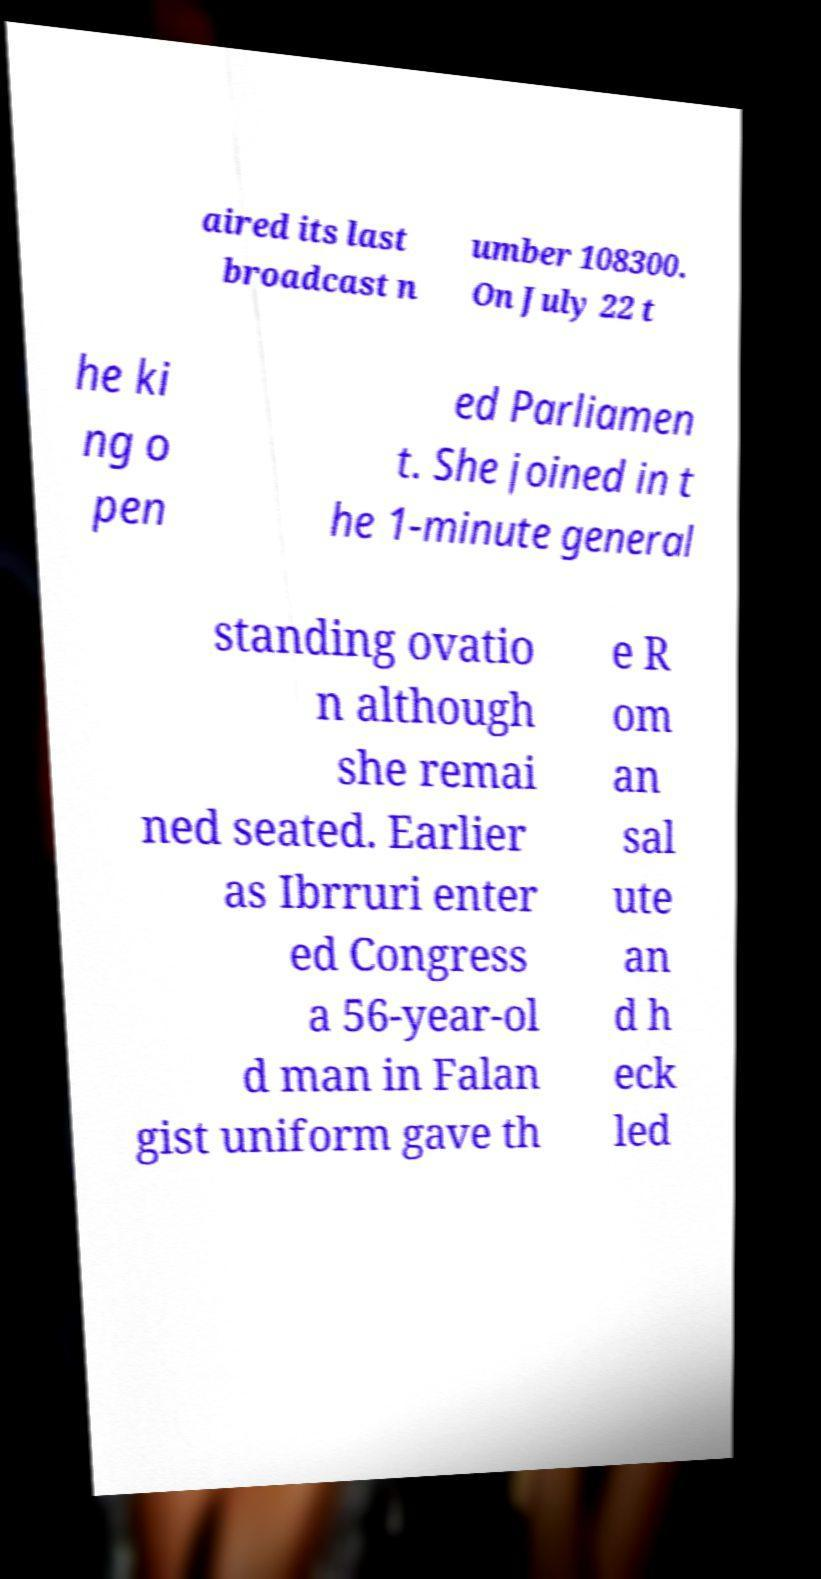Could you extract and type out the text from this image? aired its last broadcast n umber 108300. On July 22 t he ki ng o pen ed Parliamen t. She joined in t he 1-minute general standing ovatio n although she remai ned seated. Earlier as Ibrruri enter ed Congress a 56-year-ol d man in Falan gist uniform gave th e R om an sal ute an d h eck led 